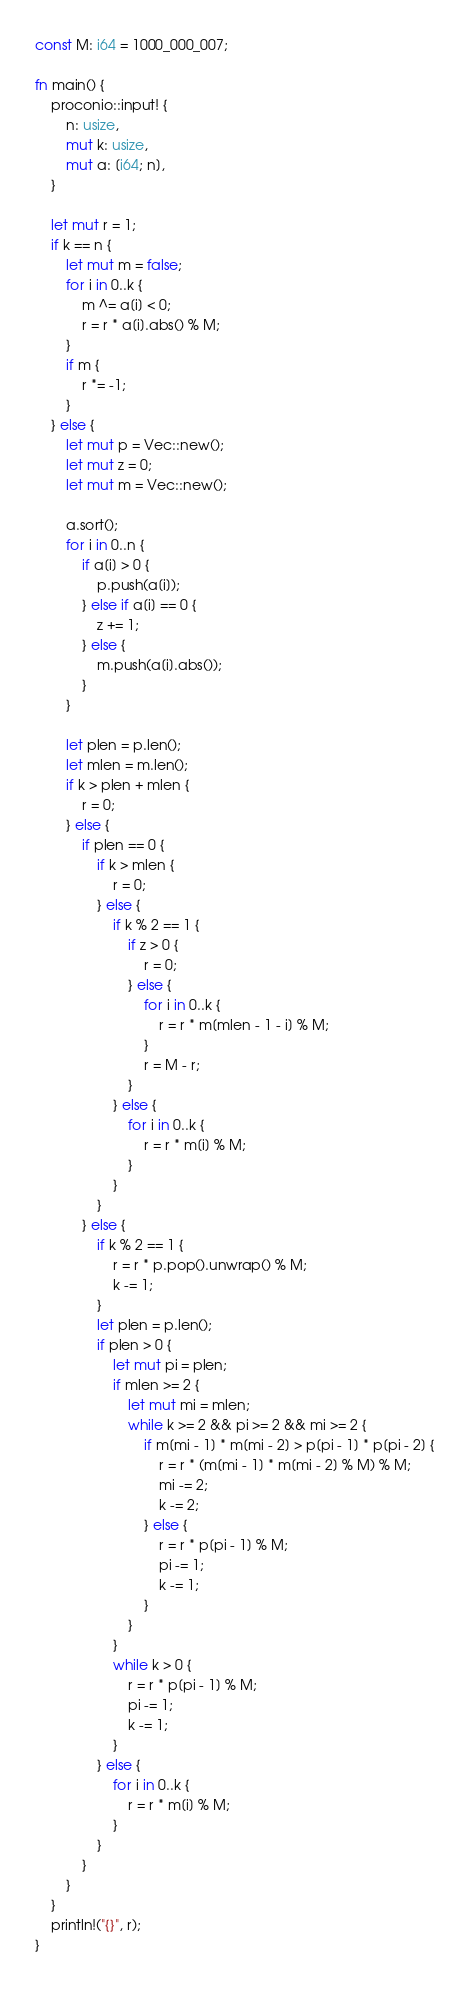<code> <loc_0><loc_0><loc_500><loc_500><_Rust_>const M: i64 = 1000_000_007;

fn main() {
    proconio::input! {
        n: usize,
        mut k: usize,
        mut a: [i64; n],
    }

    let mut r = 1;
    if k == n {
        let mut m = false;
        for i in 0..k {
            m ^= a[i] < 0;
            r = r * a[i].abs() % M;
        }
        if m {
            r *= -1;
        }
    } else {
        let mut p = Vec::new();
        let mut z = 0;
        let mut m = Vec::new();

        a.sort();
        for i in 0..n {
            if a[i] > 0 {
                p.push(a[i]);
            } else if a[i] == 0 {
                z += 1;
            } else {
                m.push(a[i].abs());
            }
        }

        let plen = p.len();
        let mlen = m.len();
        if k > plen + mlen {
            r = 0;
        } else {
            if plen == 0 {
                if k > mlen {
                    r = 0;
                } else {
                    if k % 2 == 1 {
                        if z > 0 {
                            r = 0;
                        } else {
                            for i in 0..k {
                                r = r * m[mlen - 1 - i] % M;
                            }
                            r = M - r;
                        }
                    } else {
                        for i in 0..k {
                            r = r * m[i] % M;
                        }
                    }
                }
            } else {
                if k % 2 == 1 {
                    r = r * p.pop().unwrap() % M;
                    k -= 1;
                }
                let plen = p.len();
                if plen > 0 {
                    let mut pi = plen;
                    if mlen >= 2 {
                        let mut mi = mlen;
                        while k >= 2 && pi >= 2 && mi >= 2 {
                            if m[mi - 1] * m[mi - 2] > p[pi - 1] * p[pi - 2] {
                                r = r * (m[mi - 1] * m[mi - 2] % M) % M;
                                mi -= 2;
                                k -= 2;
                            } else {
                                r = r * p[pi - 1] % M;
                                pi -= 1;
                                k -= 1;
                            }
                        }
                    }
                    while k > 0 {
                        r = r * p[pi - 1] % M;
                        pi -= 1;
                        k -= 1;
                    }
                } else {
                    for i in 0..k {
                        r = r * m[i] % M;
                    }
                }
            }
        }
    }
    println!("{}", r);
}
</code> 